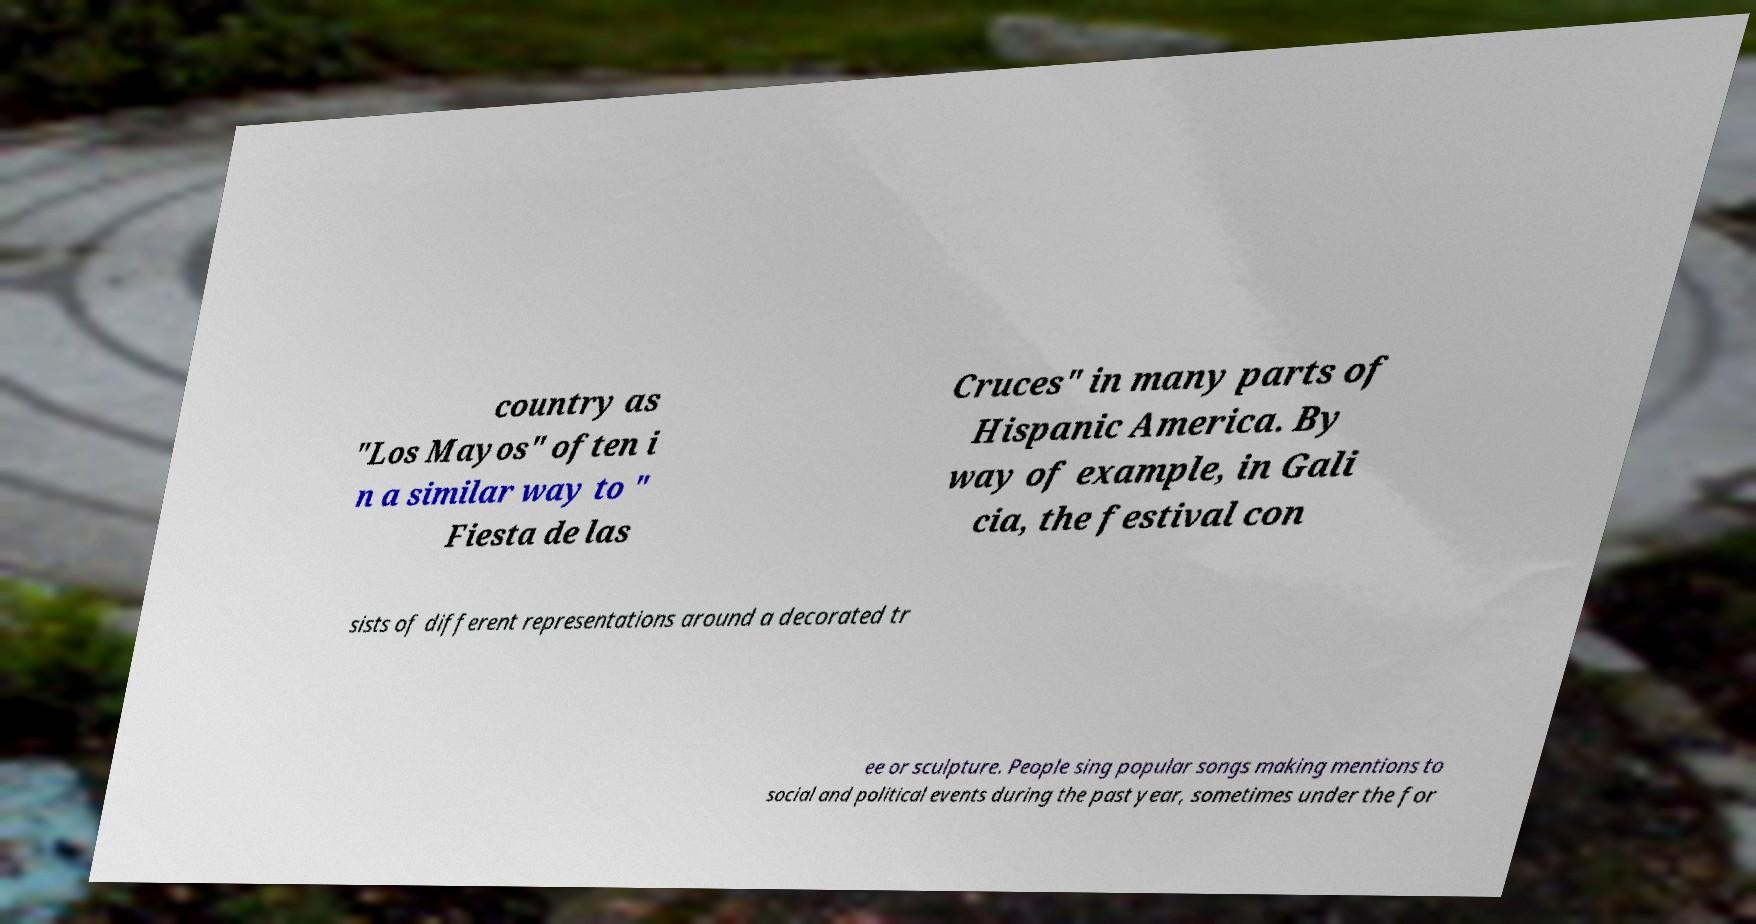There's text embedded in this image that I need extracted. Can you transcribe it verbatim? country as "Los Mayos" often i n a similar way to " Fiesta de las Cruces" in many parts of Hispanic America. By way of example, in Gali cia, the festival con sists of different representations around a decorated tr ee or sculpture. People sing popular songs making mentions to social and political events during the past year, sometimes under the for 